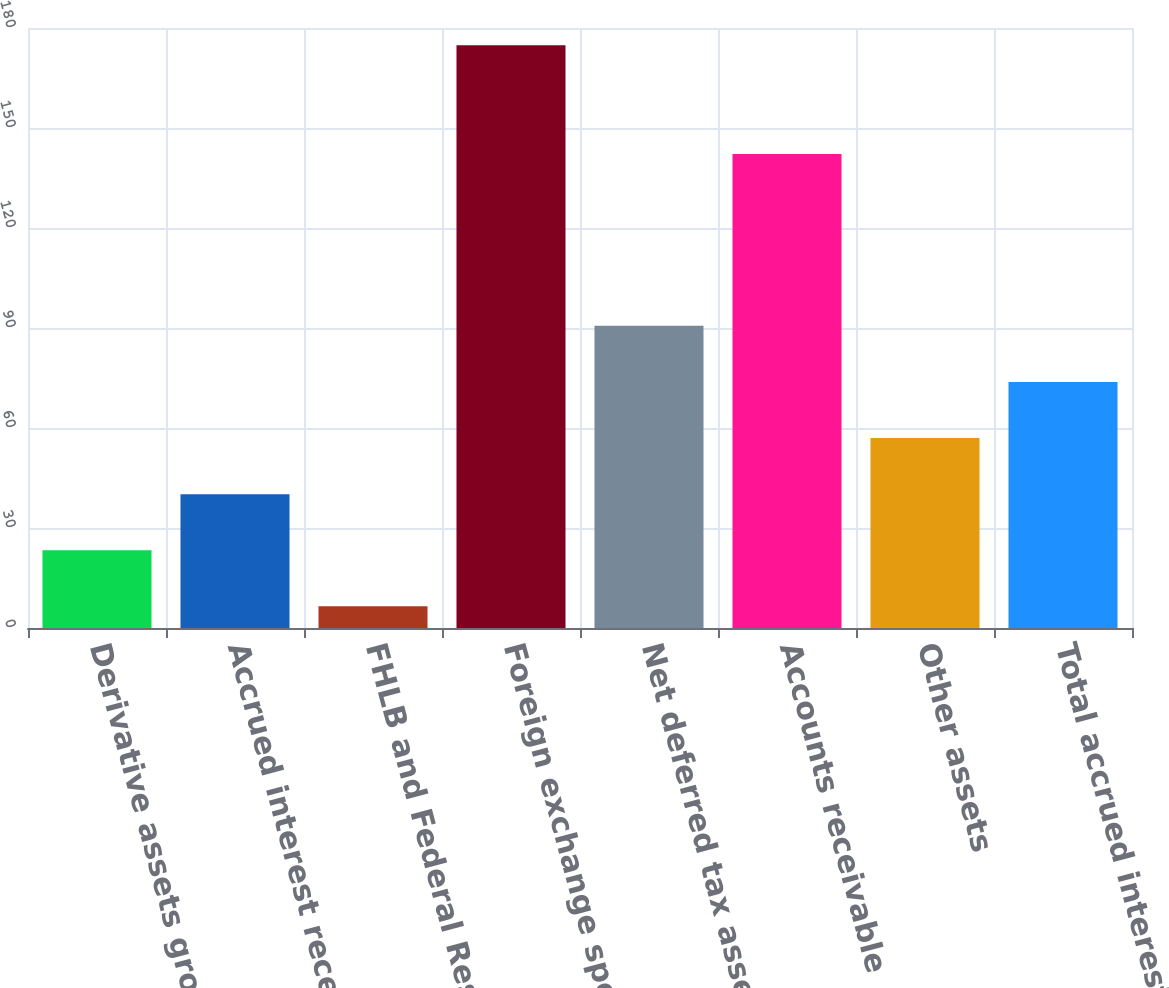Convert chart. <chart><loc_0><loc_0><loc_500><loc_500><bar_chart><fcel>Derivative assets gross (1)<fcel>Accrued interest receivable<fcel>FHLB and Federal Reserve Bank<fcel>Foreign exchange spot contract<fcel>Net deferred tax assets (2)<fcel>Accounts receivable<fcel>Other assets<fcel>Total accrued interest<nl><fcel>23.33<fcel>40.16<fcel>6.5<fcel>174.8<fcel>90.65<fcel>142.2<fcel>56.99<fcel>73.82<nl></chart> 